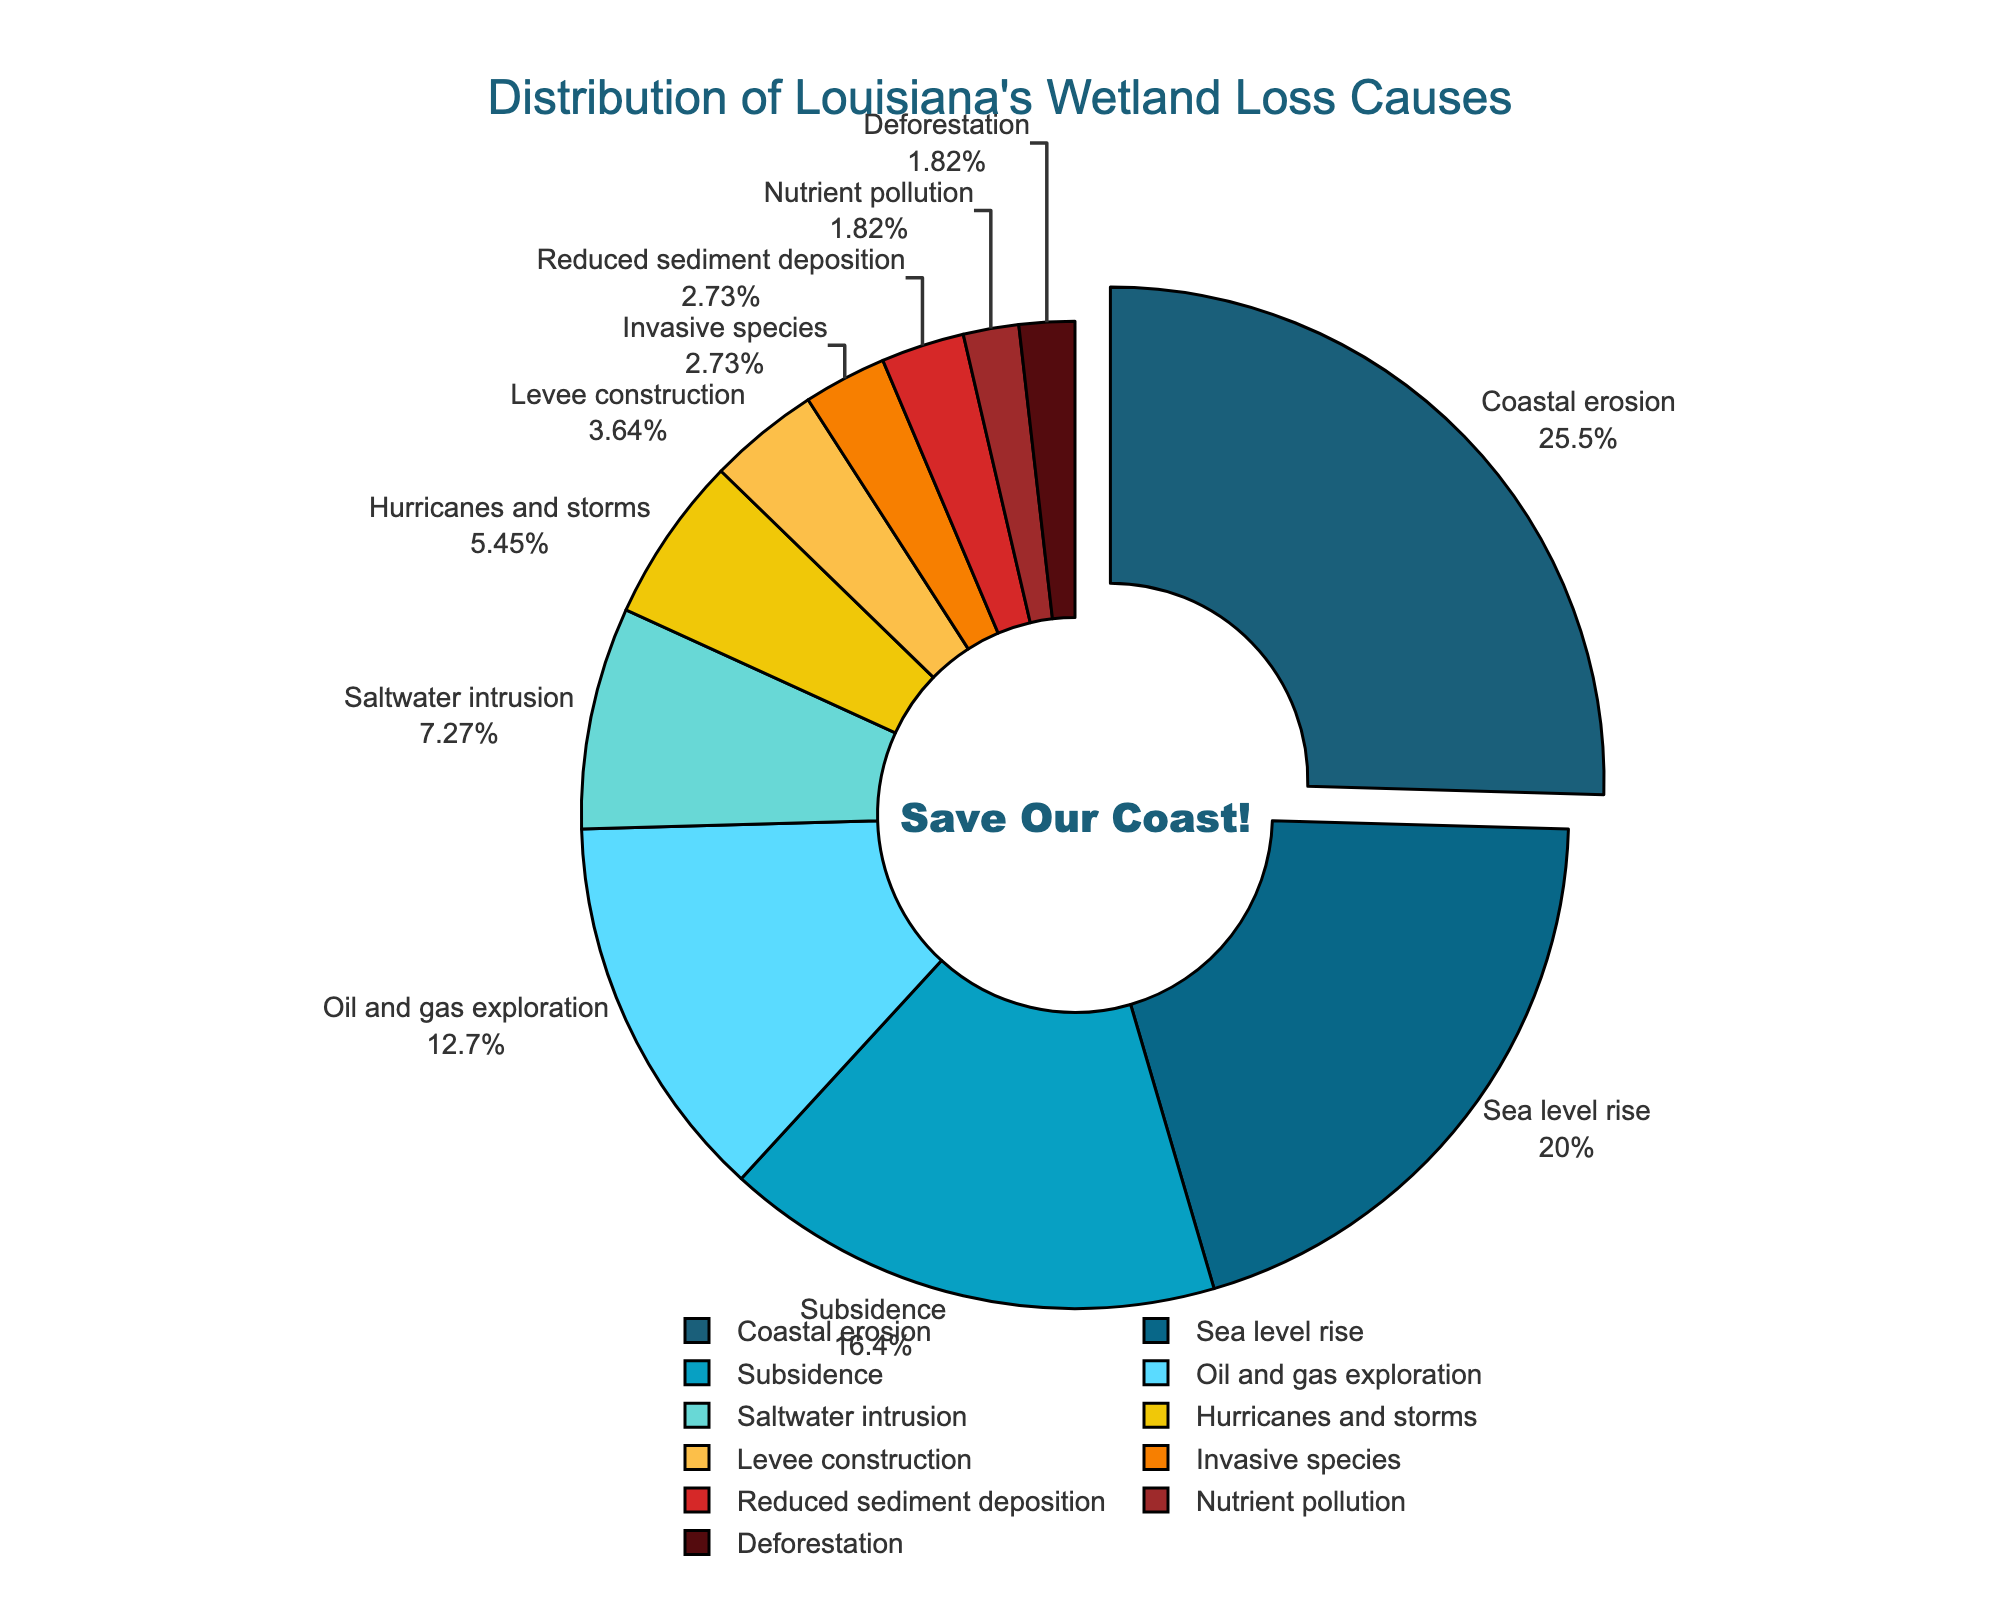How much more of Louisiana's wetland loss is caused by coastal erosion compared to oil and gas exploration? Coastal erosion accounts for 28% and oil and gas exploration accounts for 14%. The difference between these percentages is 28 - 14 = 14 percentage points.
Answer: 14 percentage points Which two causes contribute equally to Louisiana's wetland loss? Both invasive species and reduced sediment deposition contribute 3% each to Louisiana's wetland loss.
Answer: Invasive species and reduced sediment deposition What percentage of wetland loss is due to natural causes (coastal erosion, sea level rise, subsidence, saltwater intrusion, hurricanes and storms)? Sum the percentages of the natural causes: coastal erosion (28%), sea level rise (22%), subsidence (18%), saltwater intrusion (8%), hurricanes and storms (6%). Total = 28 + 22 + 18 + 8 + 6 = 82%.
Answer: 82% How do the combined contributions of nutrient pollution and deforestation compare to the contribution of saltwater intrusion? Nutrient pollution contributes 2% and deforestation contributes 2%, summing up to 2 + 2 = 4%. Saltwater intrusion contributes 8%. Therefore, 4% is half of 8%.
Answer: 4 percentage points (half) Which cause of wetland loss is shown with a small slice in a red shade? The small red slice represents deforestation, which contributes 2% to wetland loss. This is visually represented by a small slice shaded in red.
Answer: Deforestation What is the second most significant cause of Louisiana's wetland loss? The second largest slice, representing 22%, corresponds to sea level rise.
Answer: Sea level rise Which cause of wetland loss has the closest contribution percentage to the sum of reduced sediment deposition and nutrient pollution? Levee construction has a contribution of 4%. The sum of reduced sediment deposition (3%) and nutrient pollution (2%) is 3 + 2 = 5%, which is closest to 4%.
Answer: Levee construction 